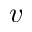<formula> <loc_0><loc_0><loc_500><loc_500>v</formula> 